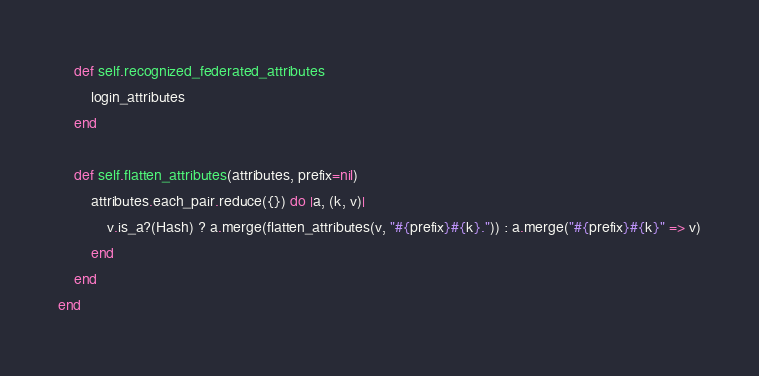Convert code to text. <code><loc_0><loc_0><loc_500><loc_500><_Ruby_>    def self.recognized_federated_attributes
        login_attributes
    end

    def self.flatten_attributes(attributes, prefix=nil)
        attributes.each_pair.reduce({}) do |a, (k, v)|
            v.is_a?(Hash) ? a.merge(flatten_attributes(v, "#{prefix}#{k}.")) : a.merge("#{prefix}#{k}" => v)
        end
    end
end</code> 